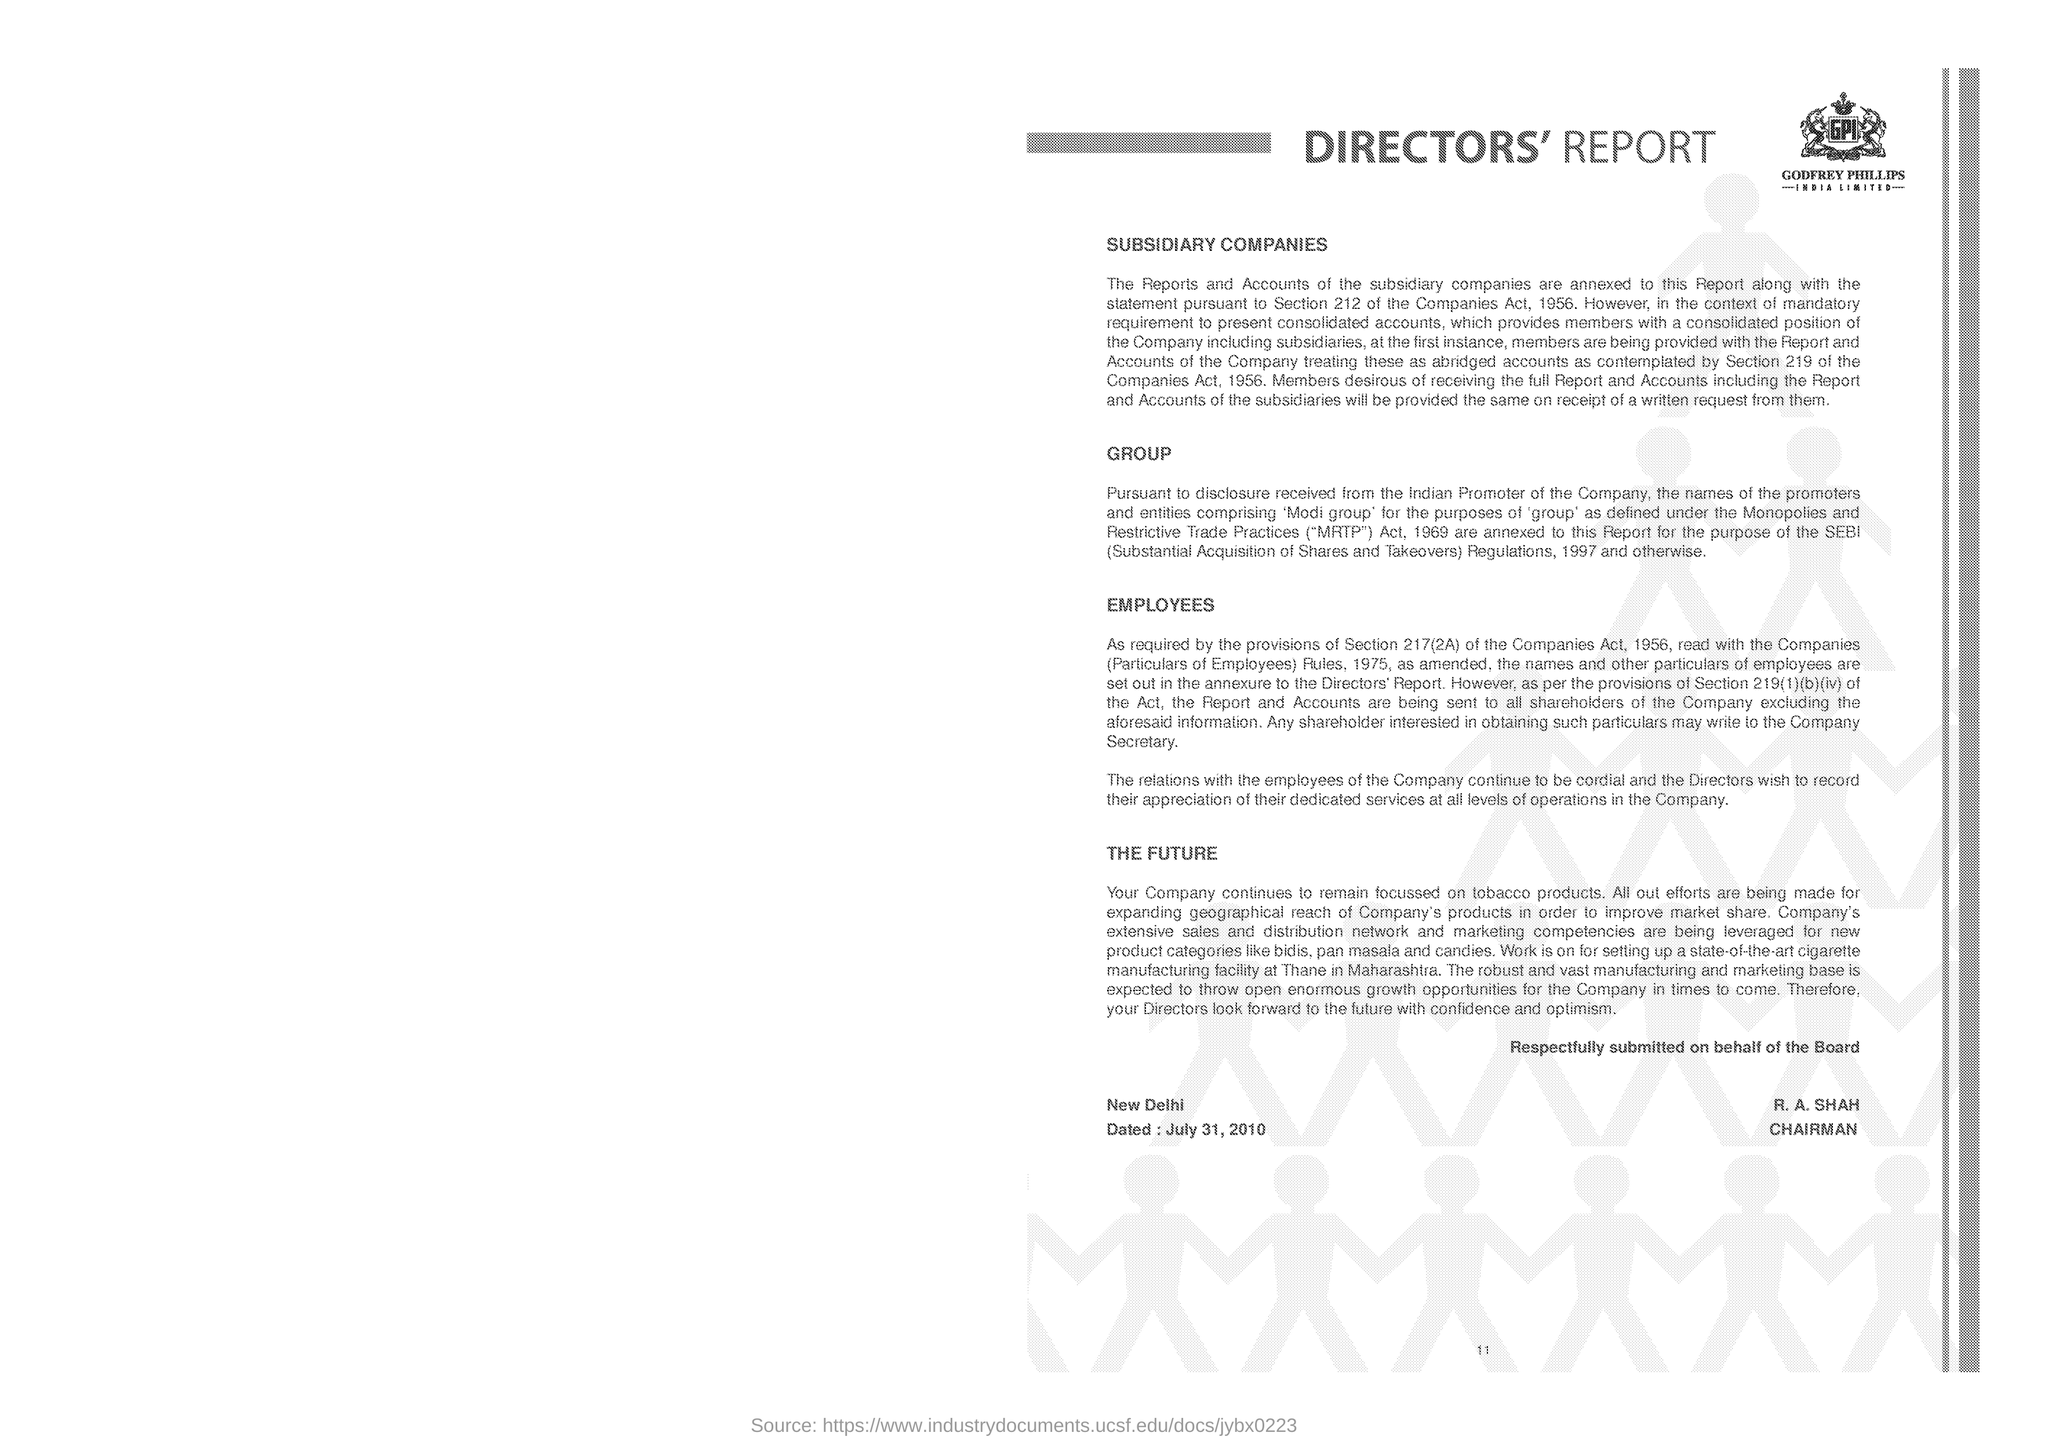Draw attention to some important aspects in this diagram. The construction of a cutting-edge cigarette manufacturing plant is currently underway in Thane, Maharashtra. The heading of the document is 'Directors' Report.' The first heading under the subtitle 'SUBSIDIARY COMPANIES' is 'What is the first side heading given? SUBSIDIARY COMPANIES..'. The place mentioned above is New Delhi, dated. Rahul A. Shah has been designated as the Chairman. 